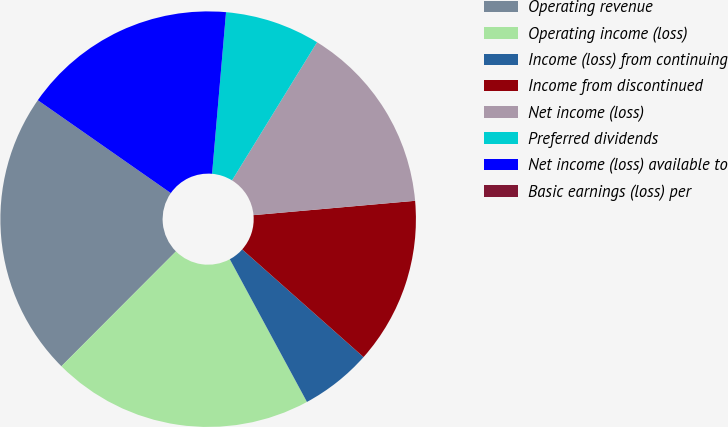Convert chart. <chart><loc_0><loc_0><loc_500><loc_500><pie_chart><fcel>Operating revenue<fcel>Operating income (loss)<fcel>Income (loss) from continuing<fcel>Income from discontinued<fcel>Net income (loss)<fcel>Preferred dividends<fcel>Net income (loss) available to<fcel>Basic earnings (loss) per<nl><fcel>22.22%<fcel>20.37%<fcel>5.56%<fcel>12.96%<fcel>14.81%<fcel>7.41%<fcel>16.67%<fcel>0.0%<nl></chart> 